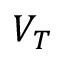<formula> <loc_0><loc_0><loc_500><loc_500>V _ { T }</formula> 